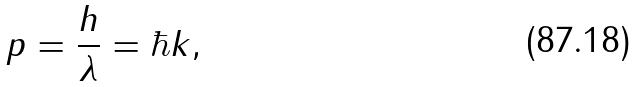Convert formula to latex. <formula><loc_0><loc_0><loc_500><loc_500>p = { \frac { h } { \lambda } } = \hbar { k } ,</formula> 